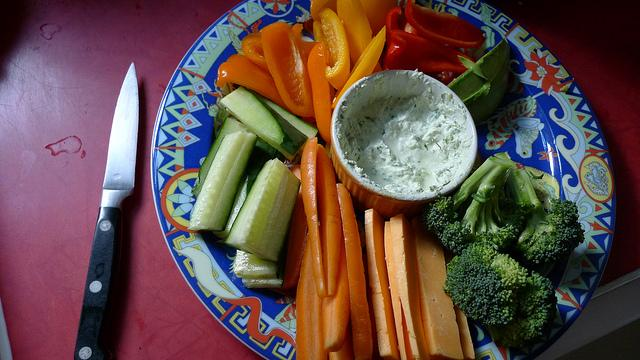What is the white substance in the middle of the plate used for?

Choices:
A) rubbing
B) dipping
C) pasting
D) drinking dipping 